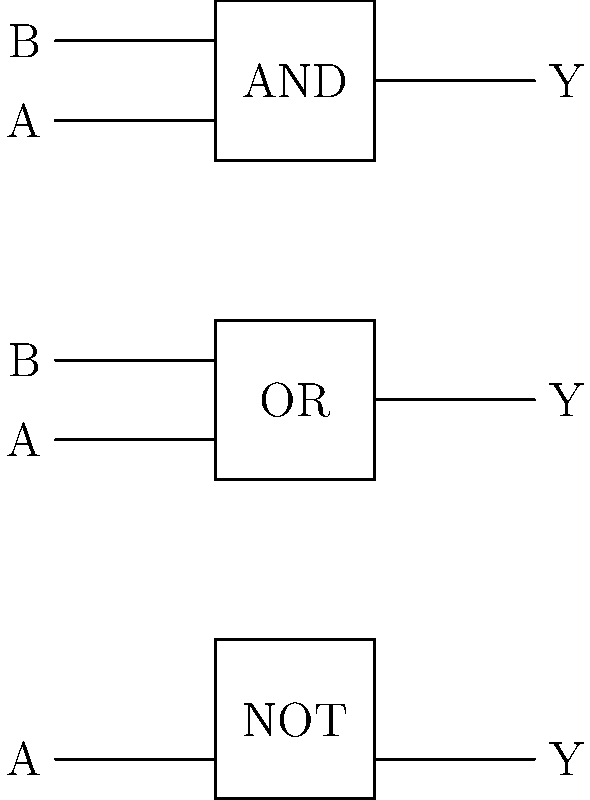As a technology enthusiast from Zimbabwe, you're studying basic logic gates. Given the circuit symbols for AND, OR, and NOT gates shown above, which of these gates would produce an output of 1 when both inputs are 0? Let's analyze each gate's behavior step-by-step:

1. AND Gate:
   - Output is 1 only when both inputs are 1
   - When both inputs are 0, output is 0

2. OR Gate:
   - Output is 1 when at least one input is 1
   - When both inputs are 0, output is 0

3. NOT Gate:
   - Output is the opposite of the input
   - When input is 0, output is 1
   - When input is 1, output is 0

The question asks for a gate that produces an output of 1 when both inputs are 0. Looking at our analysis:

- AND gate: 0 AND 0 = 0 (doesn't meet the criteria)
- OR gate: 0 OR 0 = 0 (doesn't meet the criteria)
- NOT gate: NOT 0 = 1 (meets the criteria, but it only has one input)

Since the NOT gate is the only one that can produce a 1 output from a 0 input, it's the closest to meeting the criteria. However, it's important to note that the NOT gate only has one input, not two as specified in the question.

In reality, to get a 1 output when both inputs are 0 using the gates shown, we would need to combine gates. For example, we could use a NOR gate (an OR gate followed by a NOT gate), which is not shown in the diagram.
Answer: None of the shown gates; a NOR gate would be required. 